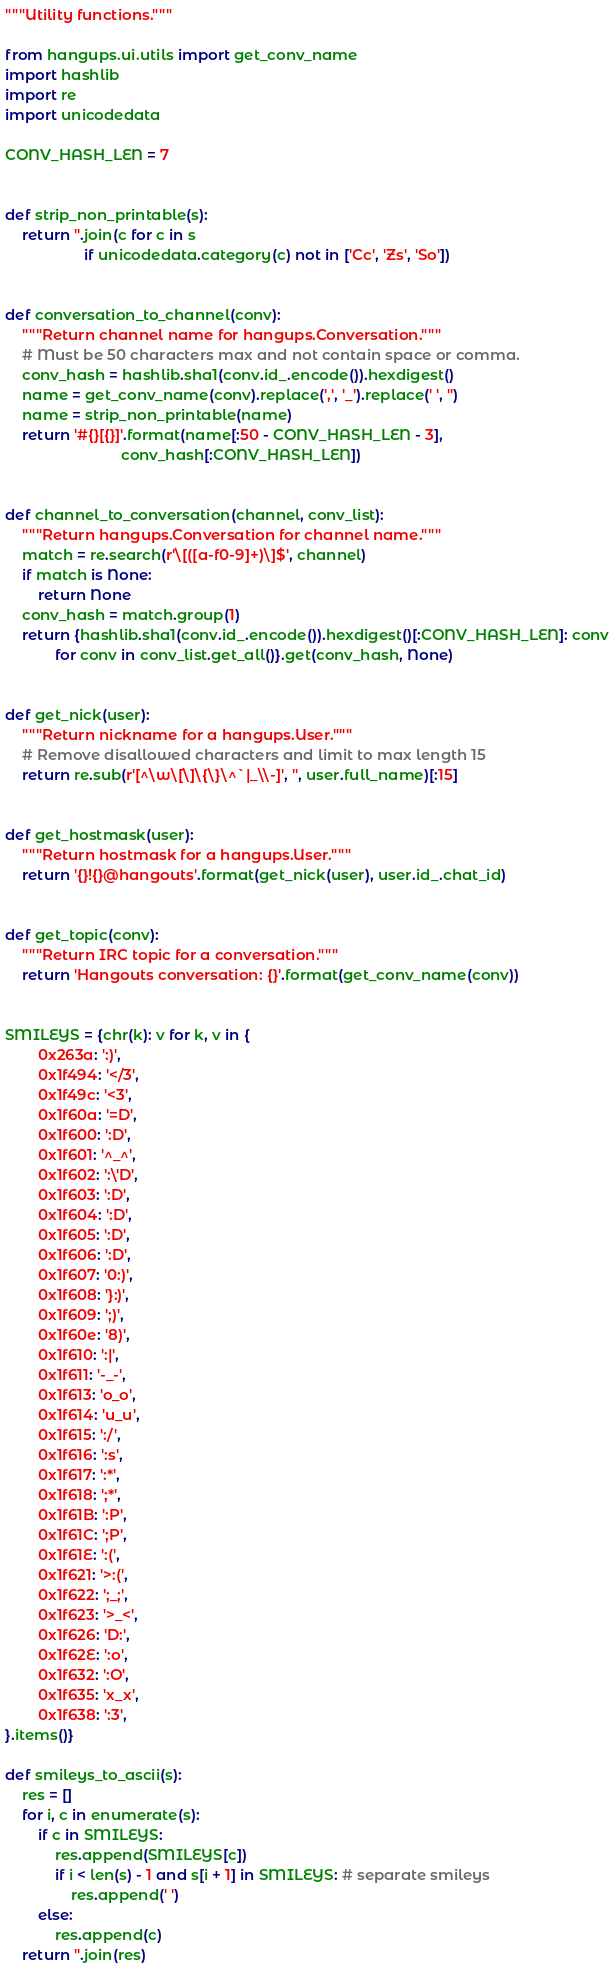Convert code to text. <code><loc_0><loc_0><loc_500><loc_500><_Python_>"""Utility functions."""

from hangups.ui.utils import get_conv_name
import hashlib
import re
import unicodedata

CONV_HASH_LEN = 7


def strip_non_printable(s):
    return ''.join(c for c in s
                   if unicodedata.category(c) not in ['Cc', 'Zs', 'So'])


def conversation_to_channel(conv):
    """Return channel name for hangups.Conversation."""
    # Must be 50 characters max and not contain space or comma.
    conv_hash = hashlib.sha1(conv.id_.encode()).hexdigest()
    name = get_conv_name(conv).replace(',', '_').replace(' ', '')
    name = strip_non_printable(name)
    return '#{}[{}]'.format(name[:50 - CONV_HASH_LEN - 3],
                            conv_hash[:CONV_HASH_LEN])


def channel_to_conversation(channel, conv_list):
    """Return hangups.Conversation for channel name."""
    match = re.search(r'\[([a-f0-9]+)\]$', channel)
    if match is None:
        return None
    conv_hash = match.group(1)
    return {hashlib.sha1(conv.id_.encode()).hexdigest()[:CONV_HASH_LEN]: conv
            for conv in conv_list.get_all()}.get(conv_hash, None)


def get_nick(user):
    """Return nickname for a hangups.User."""
    # Remove disallowed characters and limit to max length 15
    return re.sub(r'[^\w\[\]\{\}\^`|_\\-]', '', user.full_name)[:15]


def get_hostmask(user):
    """Return hostmask for a hangups.User."""
    return '{}!{}@hangouts'.format(get_nick(user), user.id_.chat_id)


def get_topic(conv):
    """Return IRC topic for a conversation."""
    return 'Hangouts conversation: {}'.format(get_conv_name(conv))


SMILEYS = {chr(k): v for k, v in {
        0x263a: ':)',
        0x1f494: '</3',
        0x1f49c: '<3',
        0x1f60a: '=D',
        0x1f600: ':D',
        0x1f601: '^_^',
        0x1f602: ':\'D',
        0x1f603: ':D',
        0x1f604: ':D',
        0x1f605: ':D',
        0x1f606: ':D',
        0x1f607: '0:)',
        0x1f608: '}:)',
        0x1f609: ';)',
        0x1f60e: '8)',
        0x1f610: ':|',
        0x1f611: '-_-',
        0x1f613: 'o_o',
        0x1f614: 'u_u',
        0x1f615: ':/',
        0x1f616: ':s',
        0x1f617: ':*',
        0x1f618: ';*',
        0x1f61B: ':P',
        0x1f61C: ';P',
        0x1f61E: ':(',
        0x1f621: '>:(',
        0x1f622: ';_;',
        0x1f623: '>_<',
        0x1f626: 'D:',
        0x1f62E: ':o',
        0x1f632: ':O',
        0x1f635: 'x_x',
        0x1f638: ':3',
}.items()}

def smileys_to_ascii(s):
    res = []
    for i, c in enumerate(s):
        if c in SMILEYS:
            res.append(SMILEYS[c])
            if i < len(s) - 1 and s[i + 1] in SMILEYS: # separate smileys
                res.append(' ')
        else:
            res.append(c)
    return ''.join(res)
</code> 